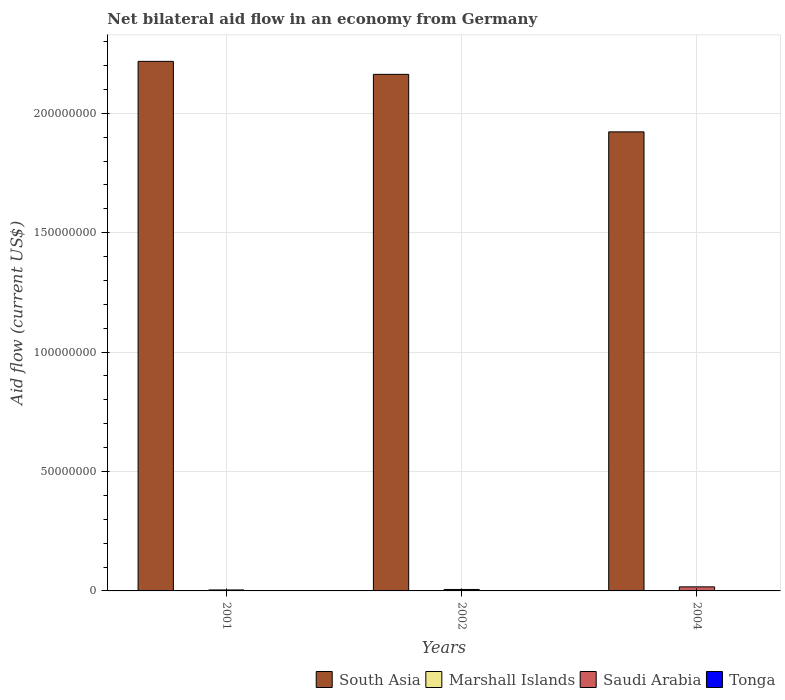How many different coloured bars are there?
Your answer should be very brief. 3. How many groups of bars are there?
Provide a succinct answer. 3. Are the number of bars on each tick of the X-axis equal?
Make the answer very short. Yes. What is the label of the 3rd group of bars from the left?
Your answer should be very brief. 2004. In how many cases, is the number of bars for a given year not equal to the number of legend labels?
Offer a very short reply. 3. What is the net bilateral aid flow in South Asia in 2001?
Ensure brevity in your answer.  2.22e+08. Across all years, what is the maximum net bilateral aid flow in Saudi Arabia?
Your answer should be compact. 1.70e+06. Across all years, what is the minimum net bilateral aid flow in South Asia?
Make the answer very short. 1.92e+08. What is the total net bilateral aid flow in Marshall Islands in the graph?
Ensure brevity in your answer.  3.00e+04. What is the difference between the net bilateral aid flow in Marshall Islands in 2001 and that in 2002?
Keep it short and to the point. 0. What is the difference between the net bilateral aid flow in Tonga in 2001 and the net bilateral aid flow in Marshall Islands in 2002?
Your response must be concise. -10000. What is the average net bilateral aid flow in Marshall Islands per year?
Provide a short and direct response. 10000. In the year 2002, what is the difference between the net bilateral aid flow in Saudi Arabia and net bilateral aid flow in South Asia?
Give a very brief answer. -2.16e+08. What is the ratio of the net bilateral aid flow in Saudi Arabia in 2002 to that in 2004?
Provide a succinct answer. 0.36. Is the net bilateral aid flow in Marshall Islands in 2001 less than that in 2004?
Offer a very short reply. No. Is the difference between the net bilateral aid flow in Saudi Arabia in 2001 and 2004 greater than the difference between the net bilateral aid flow in South Asia in 2001 and 2004?
Your answer should be compact. No. What is the difference between the highest and the second highest net bilateral aid flow in South Asia?
Provide a succinct answer. 5.44e+06. What is the difference between the highest and the lowest net bilateral aid flow in South Asia?
Give a very brief answer. 2.95e+07. Is it the case that in every year, the sum of the net bilateral aid flow in South Asia and net bilateral aid flow in Saudi Arabia is greater than the sum of net bilateral aid flow in Marshall Islands and net bilateral aid flow in Tonga?
Offer a very short reply. No. Is it the case that in every year, the sum of the net bilateral aid flow in Marshall Islands and net bilateral aid flow in Saudi Arabia is greater than the net bilateral aid flow in Tonga?
Give a very brief answer. Yes. How many years are there in the graph?
Offer a terse response. 3. What is the difference between two consecutive major ticks on the Y-axis?
Give a very brief answer. 5.00e+07. Does the graph contain grids?
Ensure brevity in your answer.  Yes. How many legend labels are there?
Provide a short and direct response. 4. How are the legend labels stacked?
Give a very brief answer. Horizontal. What is the title of the graph?
Your response must be concise. Net bilateral aid flow in an economy from Germany. What is the Aid flow (current US$) in South Asia in 2001?
Make the answer very short. 2.22e+08. What is the Aid flow (current US$) in Marshall Islands in 2001?
Ensure brevity in your answer.  10000. What is the Aid flow (current US$) of Tonga in 2001?
Offer a terse response. 0. What is the Aid flow (current US$) in South Asia in 2002?
Ensure brevity in your answer.  2.16e+08. What is the Aid flow (current US$) of Saudi Arabia in 2002?
Provide a short and direct response. 6.10e+05. What is the Aid flow (current US$) of South Asia in 2004?
Offer a terse response. 1.92e+08. What is the Aid flow (current US$) in Marshall Islands in 2004?
Your response must be concise. 10000. What is the Aid flow (current US$) of Saudi Arabia in 2004?
Ensure brevity in your answer.  1.70e+06. Across all years, what is the maximum Aid flow (current US$) in South Asia?
Provide a succinct answer. 2.22e+08. Across all years, what is the maximum Aid flow (current US$) in Saudi Arabia?
Keep it short and to the point. 1.70e+06. Across all years, what is the minimum Aid flow (current US$) of South Asia?
Your response must be concise. 1.92e+08. Across all years, what is the minimum Aid flow (current US$) of Marshall Islands?
Provide a short and direct response. 10000. What is the total Aid flow (current US$) in South Asia in the graph?
Make the answer very short. 6.30e+08. What is the total Aid flow (current US$) in Marshall Islands in the graph?
Provide a succinct answer. 3.00e+04. What is the total Aid flow (current US$) in Saudi Arabia in the graph?
Give a very brief answer. 2.72e+06. What is the total Aid flow (current US$) in Tonga in the graph?
Provide a succinct answer. 0. What is the difference between the Aid flow (current US$) in South Asia in 2001 and that in 2002?
Offer a terse response. 5.44e+06. What is the difference between the Aid flow (current US$) of Marshall Islands in 2001 and that in 2002?
Offer a terse response. 0. What is the difference between the Aid flow (current US$) in Saudi Arabia in 2001 and that in 2002?
Offer a very short reply. -2.00e+05. What is the difference between the Aid flow (current US$) of South Asia in 2001 and that in 2004?
Make the answer very short. 2.95e+07. What is the difference between the Aid flow (current US$) in Marshall Islands in 2001 and that in 2004?
Offer a very short reply. 0. What is the difference between the Aid flow (current US$) in Saudi Arabia in 2001 and that in 2004?
Ensure brevity in your answer.  -1.29e+06. What is the difference between the Aid flow (current US$) in South Asia in 2002 and that in 2004?
Your answer should be very brief. 2.41e+07. What is the difference between the Aid flow (current US$) in Saudi Arabia in 2002 and that in 2004?
Ensure brevity in your answer.  -1.09e+06. What is the difference between the Aid flow (current US$) of South Asia in 2001 and the Aid flow (current US$) of Marshall Islands in 2002?
Your answer should be very brief. 2.22e+08. What is the difference between the Aid flow (current US$) in South Asia in 2001 and the Aid flow (current US$) in Saudi Arabia in 2002?
Give a very brief answer. 2.21e+08. What is the difference between the Aid flow (current US$) in Marshall Islands in 2001 and the Aid flow (current US$) in Saudi Arabia in 2002?
Offer a very short reply. -6.00e+05. What is the difference between the Aid flow (current US$) of South Asia in 2001 and the Aid flow (current US$) of Marshall Islands in 2004?
Offer a terse response. 2.22e+08. What is the difference between the Aid flow (current US$) in South Asia in 2001 and the Aid flow (current US$) in Saudi Arabia in 2004?
Ensure brevity in your answer.  2.20e+08. What is the difference between the Aid flow (current US$) of Marshall Islands in 2001 and the Aid flow (current US$) of Saudi Arabia in 2004?
Offer a terse response. -1.69e+06. What is the difference between the Aid flow (current US$) of South Asia in 2002 and the Aid flow (current US$) of Marshall Islands in 2004?
Provide a succinct answer. 2.16e+08. What is the difference between the Aid flow (current US$) in South Asia in 2002 and the Aid flow (current US$) in Saudi Arabia in 2004?
Ensure brevity in your answer.  2.15e+08. What is the difference between the Aid flow (current US$) of Marshall Islands in 2002 and the Aid flow (current US$) of Saudi Arabia in 2004?
Your answer should be very brief. -1.69e+06. What is the average Aid flow (current US$) of South Asia per year?
Offer a very short reply. 2.10e+08. What is the average Aid flow (current US$) of Saudi Arabia per year?
Your answer should be very brief. 9.07e+05. What is the average Aid flow (current US$) in Tonga per year?
Your answer should be very brief. 0. In the year 2001, what is the difference between the Aid flow (current US$) in South Asia and Aid flow (current US$) in Marshall Islands?
Provide a short and direct response. 2.22e+08. In the year 2001, what is the difference between the Aid flow (current US$) of South Asia and Aid flow (current US$) of Saudi Arabia?
Give a very brief answer. 2.21e+08. In the year 2001, what is the difference between the Aid flow (current US$) in Marshall Islands and Aid flow (current US$) in Saudi Arabia?
Offer a terse response. -4.00e+05. In the year 2002, what is the difference between the Aid flow (current US$) in South Asia and Aid flow (current US$) in Marshall Islands?
Keep it short and to the point. 2.16e+08. In the year 2002, what is the difference between the Aid flow (current US$) in South Asia and Aid flow (current US$) in Saudi Arabia?
Offer a terse response. 2.16e+08. In the year 2002, what is the difference between the Aid flow (current US$) of Marshall Islands and Aid flow (current US$) of Saudi Arabia?
Your answer should be compact. -6.00e+05. In the year 2004, what is the difference between the Aid flow (current US$) in South Asia and Aid flow (current US$) in Marshall Islands?
Give a very brief answer. 1.92e+08. In the year 2004, what is the difference between the Aid flow (current US$) in South Asia and Aid flow (current US$) in Saudi Arabia?
Ensure brevity in your answer.  1.91e+08. In the year 2004, what is the difference between the Aid flow (current US$) of Marshall Islands and Aid flow (current US$) of Saudi Arabia?
Your answer should be very brief. -1.69e+06. What is the ratio of the Aid flow (current US$) of South Asia in 2001 to that in 2002?
Offer a very short reply. 1.03. What is the ratio of the Aid flow (current US$) of Saudi Arabia in 2001 to that in 2002?
Keep it short and to the point. 0.67. What is the ratio of the Aid flow (current US$) in South Asia in 2001 to that in 2004?
Ensure brevity in your answer.  1.15. What is the ratio of the Aid flow (current US$) in Marshall Islands in 2001 to that in 2004?
Offer a very short reply. 1. What is the ratio of the Aid flow (current US$) of Saudi Arabia in 2001 to that in 2004?
Give a very brief answer. 0.24. What is the ratio of the Aid flow (current US$) of South Asia in 2002 to that in 2004?
Your answer should be compact. 1.13. What is the ratio of the Aid flow (current US$) of Saudi Arabia in 2002 to that in 2004?
Your response must be concise. 0.36. What is the difference between the highest and the second highest Aid flow (current US$) in South Asia?
Ensure brevity in your answer.  5.44e+06. What is the difference between the highest and the second highest Aid flow (current US$) in Marshall Islands?
Give a very brief answer. 0. What is the difference between the highest and the second highest Aid flow (current US$) in Saudi Arabia?
Keep it short and to the point. 1.09e+06. What is the difference between the highest and the lowest Aid flow (current US$) of South Asia?
Offer a terse response. 2.95e+07. What is the difference between the highest and the lowest Aid flow (current US$) in Marshall Islands?
Give a very brief answer. 0. What is the difference between the highest and the lowest Aid flow (current US$) in Saudi Arabia?
Provide a succinct answer. 1.29e+06. 